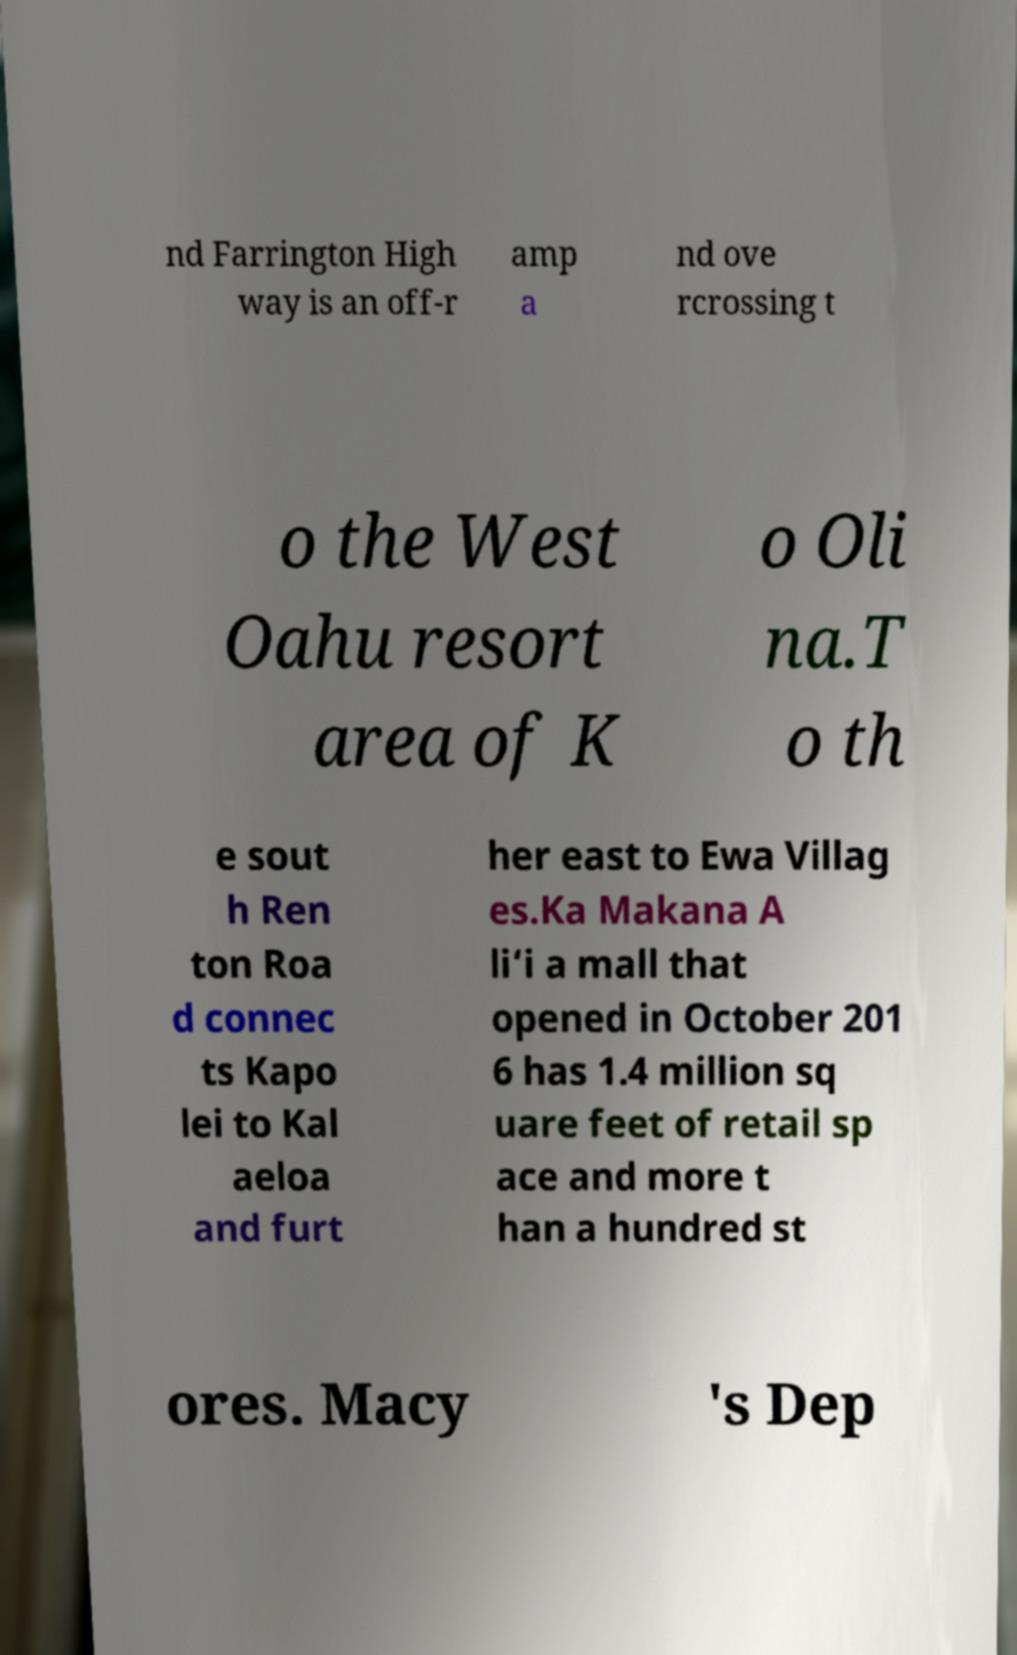For documentation purposes, I need the text within this image transcribed. Could you provide that? nd Farrington High way is an off-r amp a nd ove rcrossing t o the West Oahu resort area of K o Oli na.T o th e sout h Ren ton Roa d connec ts Kapo lei to Kal aeloa and furt her east to Ewa Villag es.Ka Makana A li‘i a mall that opened in October 201 6 has 1.4 million sq uare feet of retail sp ace and more t han a hundred st ores. Macy 's Dep 